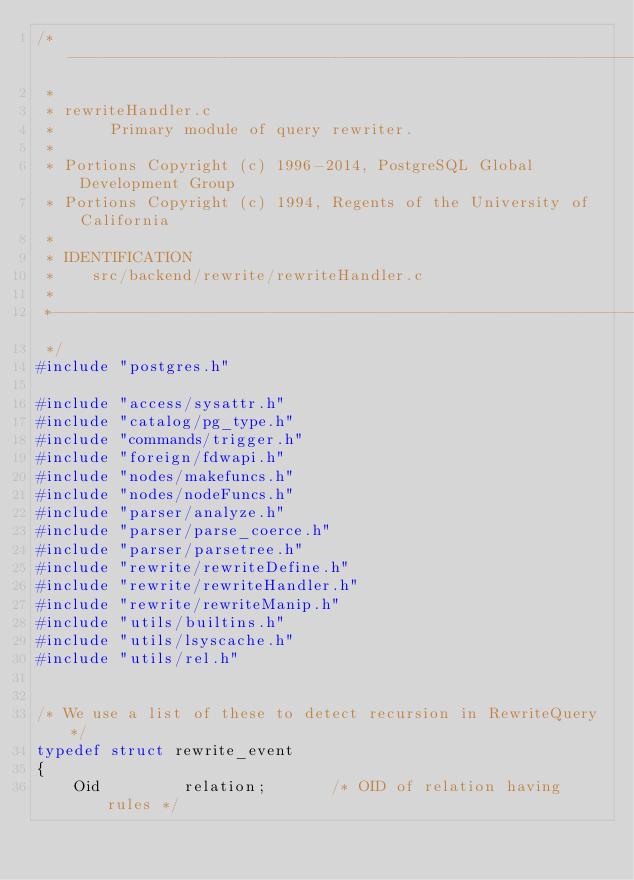<code> <loc_0><loc_0><loc_500><loc_500><_C_>/*-------------------------------------------------------------------------
 *
 * rewriteHandler.c
 *		Primary module of query rewriter.
 *
 * Portions Copyright (c) 1996-2014, PostgreSQL Global Development Group
 * Portions Copyright (c) 1994, Regents of the University of California
 *
 * IDENTIFICATION
 *	  src/backend/rewrite/rewriteHandler.c
 *
 *-------------------------------------------------------------------------
 */
#include "postgres.h"

#include "access/sysattr.h"
#include "catalog/pg_type.h"
#include "commands/trigger.h"
#include "foreign/fdwapi.h"
#include "nodes/makefuncs.h"
#include "nodes/nodeFuncs.h"
#include "parser/analyze.h"
#include "parser/parse_coerce.h"
#include "parser/parsetree.h"
#include "rewrite/rewriteDefine.h"
#include "rewrite/rewriteHandler.h"
#include "rewrite/rewriteManip.h"
#include "utils/builtins.h"
#include "utils/lsyscache.h"
#include "utils/rel.h"


/* We use a list of these to detect recursion in RewriteQuery */
typedef struct rewrite_event
{
	Oid			relation;		/* OID of relation having rules */</code> 